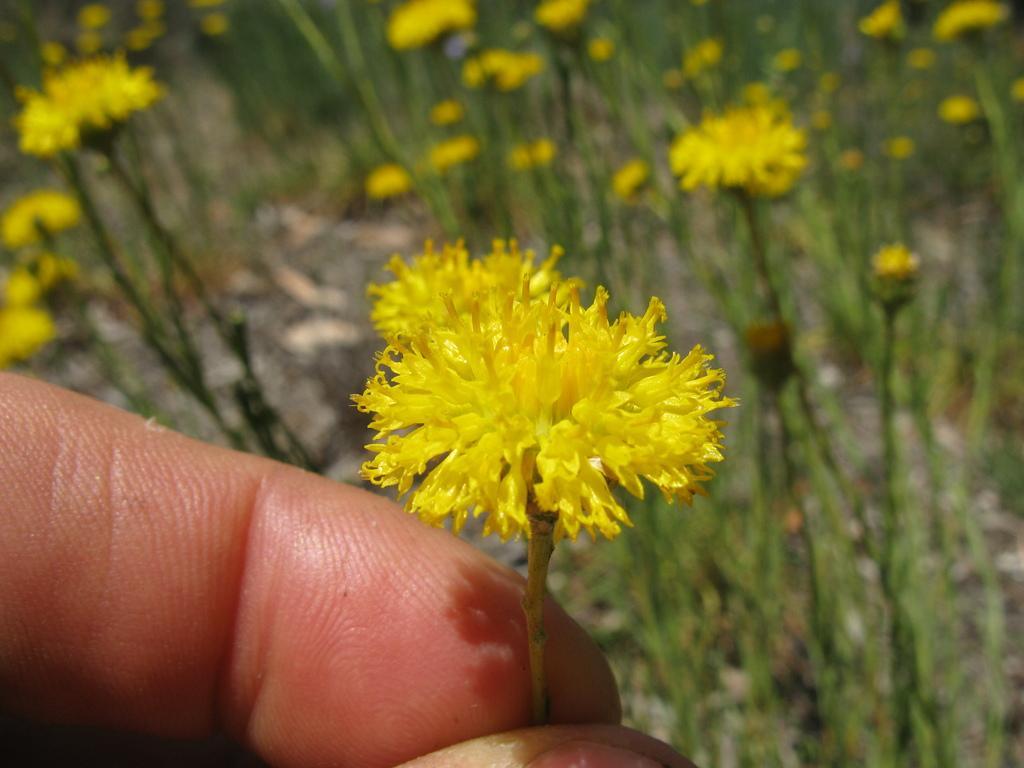How would you summarize this image in a sentence or two? In this picture there is a person holding the flower. There are yellow color flowers on the plants. 